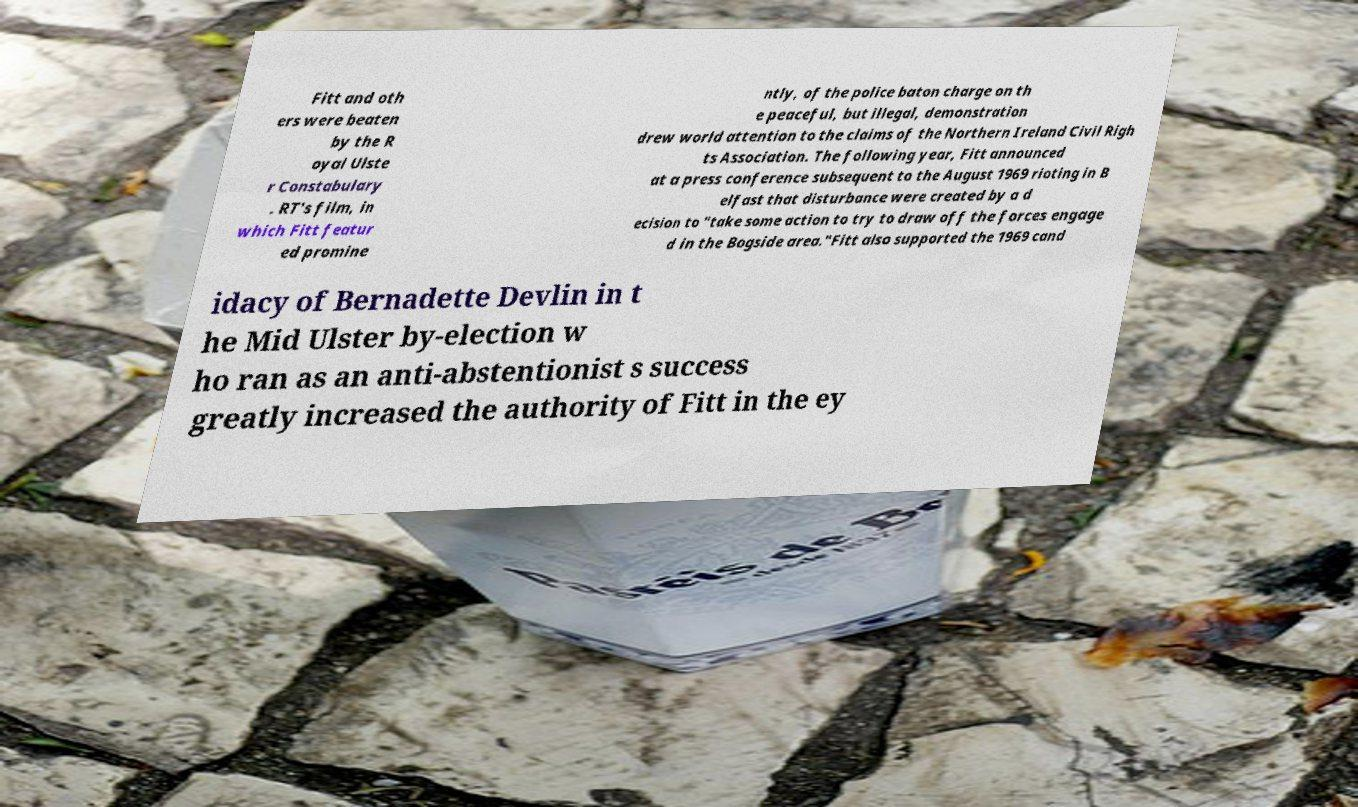For documentation purposes, I need the text within this image transcribed. Could you provide that? Fitt and oth ers were beaten by the R oyal Ulste r Constabulary . RT's film, in which Fitt featur ed promine ntly, of the police baton charge on th e peaceful, but illegal, demonstration drew world attention to the claims of the Northern Ireland Civil Righ ts Association. The following year, Fitt announced at a press conference subsequent to the August 1969 rioting in B elfast that disturbance were created by a d ecision to "take some action to try to draw off the forces engage d in the Bogside area."Fitt also supported the 1969 cand idacy of Bernadette Devlin in t he Mid Ulster by-election w ho ran as an anti-abstentionist s success greatly increased the authority of Fitt in the ey 